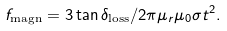Convert formula to latex. <formula><loc_0><loc_0><loc_500><loc_500>f _ { \text {magn} } = 3 \tan \delta _ { \text {loss} } / 2 \pi \mu _ { r } \mu _ { 0 } \sigma t ^ { 2 } .</formula> 